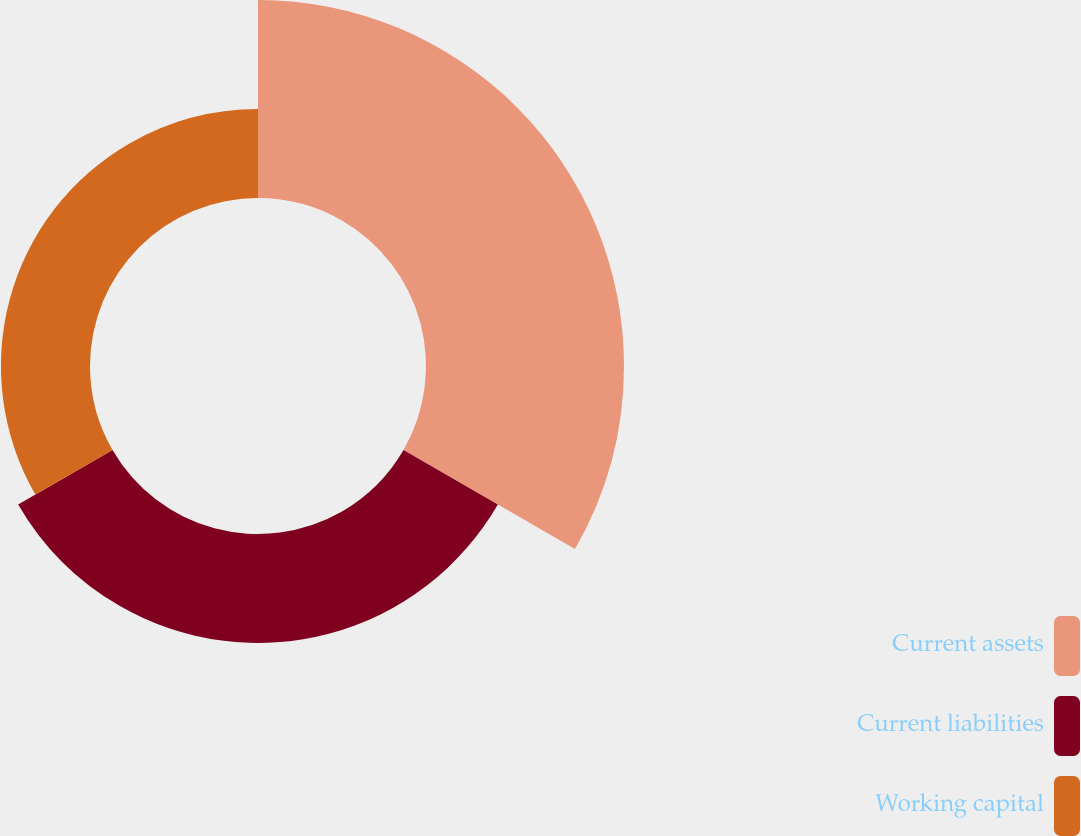Convert chart. <chart><loc_0><loc_0><loc_500><loc_500><pie_chart><fcel>Current assets<fcel>Current liabilities<fcel>Working capital<nl><fcel>50.0%<fcel>27.51%<fcel>22.49%<nl></chart> 